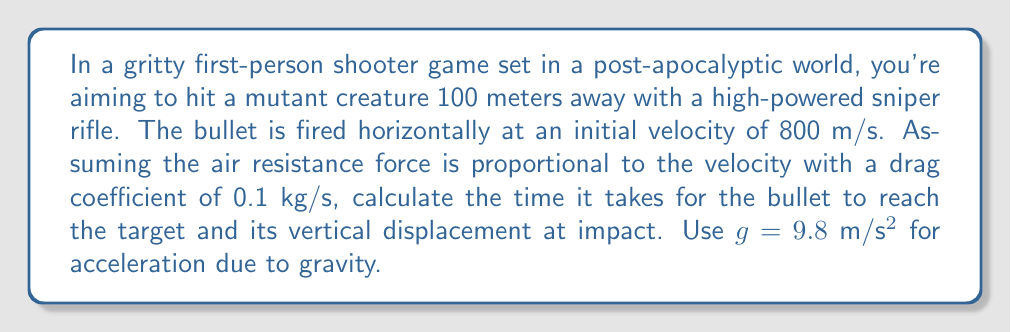Solve this math problem. Let's approach this problem step by step:

1) First, we need to set up our equations of motion. We'll use x for horizontal displacement and y for vertical displacement.

2) The horizontal motion equation, considering air resistance:
   $$\frac{d^2x}{dt^2} = -k\frac{dx}{dt}$$
   where k = 0.1 kg/s ÷ mass of the bullet

3) The vertical motion equation:
   $$\frac{d^2y}{dt^2} = -g - k\frac{dy}{dt}$$

4) For the horizontal motion, we can solve the differential equation:
   $$\frac{dx}{dt} = v_0e^{-kt}$$
   where $v_0$ = 800 m/s (initial velocity)

5) Integrating this:
   $$x = \frac{v_0}{k}(1-e^{-kt})$$

6) We know x = 100 m at the target. We can solve for t:
   $$100 = \frac{800}{k}(1-e^{-kt})$$
   $$e^{-kt} = 1 - \frac{100k}{800} = 1 - \frac{k}{8}$$
   $$t = -\frac{1}{k}\ln(1-\frac{k}{8})$$

7) For the vertical motion, we can use the equation:
   $$y = -\frac{g}{k}t + \frac{g}{k^2}(1-e^{-kt})$$

8) To find k, we need to estimate the mass of the bullet. Let's assume it's 10g or 0.01 kg.
   Then, k = 0.1 ÷ 0.01 = 10 s⁻¹

9) Plugging this into our time equation:
   $$t = -\frac{1}{10}\ln(1-\frac{10}{8}) = 0.1283 \text{ seconds}$$

10) Now we can calculate the vertical displacement:
    $$y = -\frac{9.8}{10}(0.1283) + \frac{9.8}{100}(1-e^{-10(0.1283)})$$
    $$y = -0.1257 + 0.0980(1-0.2778)$$
    $$y = -0.1257 + 0.0708 = -0.0549 \text{ meters}$$
Answer: The bullet will reach the target in approximately 0.1283 seconds and will have dropped about 5.49 cm vertically at impact. 